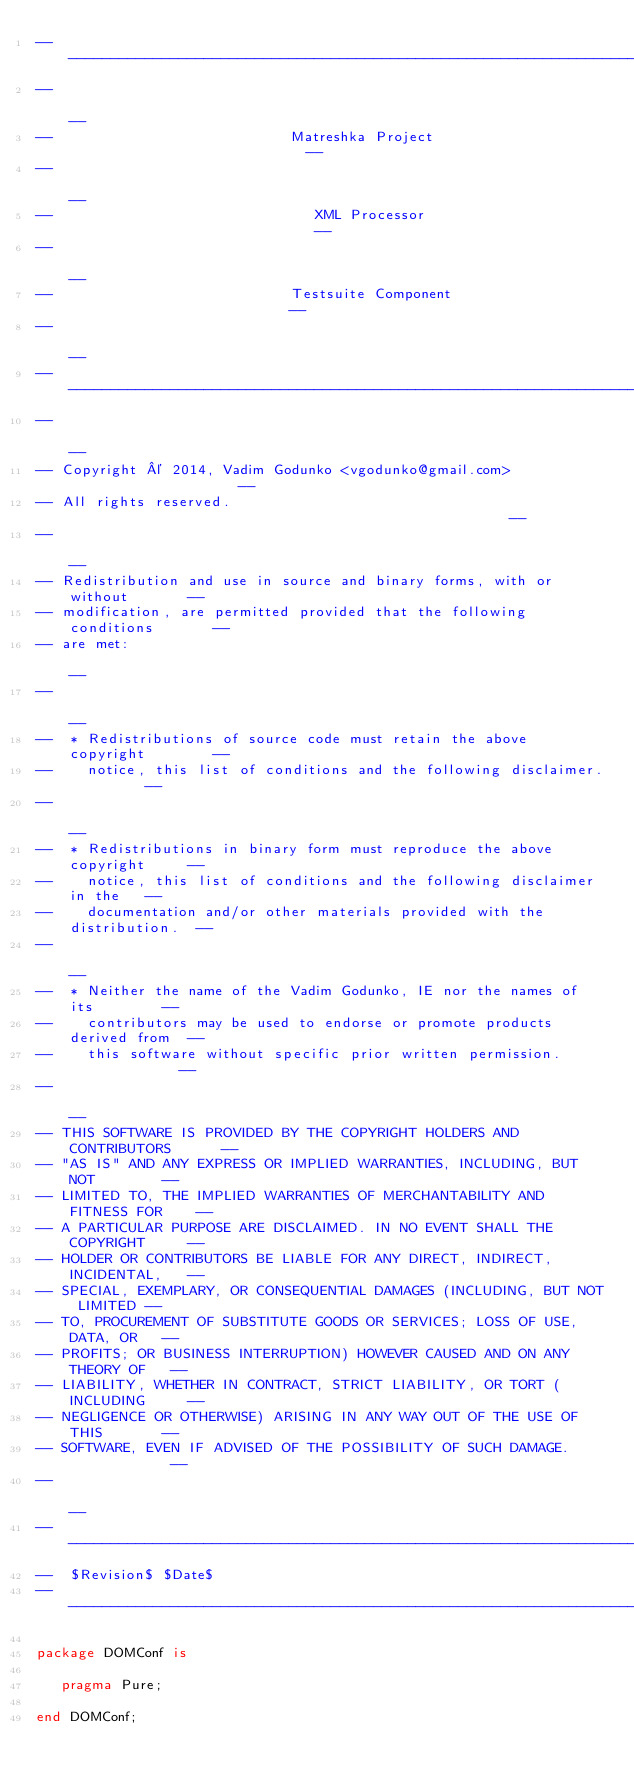Convert code to text. <code><loc_0><loc_0><loc_500><loc_500><_Ada_>------------------------------------------------------------------------------
--                                                                          --
--                            Matreshka Project                             --
--                                                                          --
--                               XML Processor                              --
--                                                                          --
--                            Testsuite Component                           --
--                                                                          --
------------------------------------------------------------------------------
--                                                                          --
-- Copyright © 2014, Vadim Godunko <vgodunko@gmail.com>                     --
-- All rights reserved.                                                     --
--                                                                          --
-- Redistribution and use in source and binary forms, with or without       --
-- modification, are permitted provided that the following conditions       --
-- are met:                                                                 --
--                                                                          --
--  * Redistributions of source code must retain the above copyright        --
--    notice, this list of conditions and the following disclaimer.         --
--                                                                          --
--  * Redistributions in binary form must reproduce the above copyright     --
--    notice, this list of conditions and the following disclaimer in the   --
--    documentation and/or other materials provided with the distribution.  --
--                                                                          --
--  * Neither the name of the Vadim Godunko, IE nor the names of its        --
--    contributors may be used to endorse or promote products derived from  --
--    this software without specific prior written permission.              --
--                                                                          --
-- THIS SOFTWARE IS PROVIDED BY THE COPYRIGHT HOLDERS AND CONTRIBUTORS      --
-- "AS IS" AND ANY EXPRESS OR IMPLIED WARRANTIES, INCLUDING, BUT NOT        --
-- LIMITED TO, THE IMPLIED WARRANTIES OF MERCHANTABILITY AND FITNESS FOR    --
-- A PARTICULAR PURPOSE ARE DISCLAIMED. IN NO EVENT SHALL THE COPYRIGHT     --
-- HOLDER OR CONTRIBUTORS BE LIABLE FOR ANY DIRECT, INDIRECT, INCIDENTAL,   --
-- SPECIAL, EXEMPLARY, OR CONSEQUENTIAL DAMAGES (INCLUDING, BUT NOT LIMITED --
-- TO, PROCUREMENT OF SUBSTITUTE GOODS OR SERVICES; LOSS OF USE, DATA, OR   --
-- PROFITS; OR BUSINESS INTERRUPTION) HOWEVER CAUSED AND ON ANY THEORY OF   --
-- LIABILITY, WHETHER IN CONTRACT, STRICT LIABILITY, OR TORT (INCLUDING     --
-- NEGLIGENCE OR OTHERWISE) ARISING IN ANY WAY OUT OF THE USE OF THIS       --
-- SOFTWARE, EVEN IF ADVISED OF THE POSSIBILITY OF SUCH DAMAGE.             --
--                                                                          --
------------------------------------------------------------------------------
--  $Revision$ $Date$
------------------------------------------------------------------------------

package DOMConf is

   pragma Pure;

end DOMConf;
</code> 